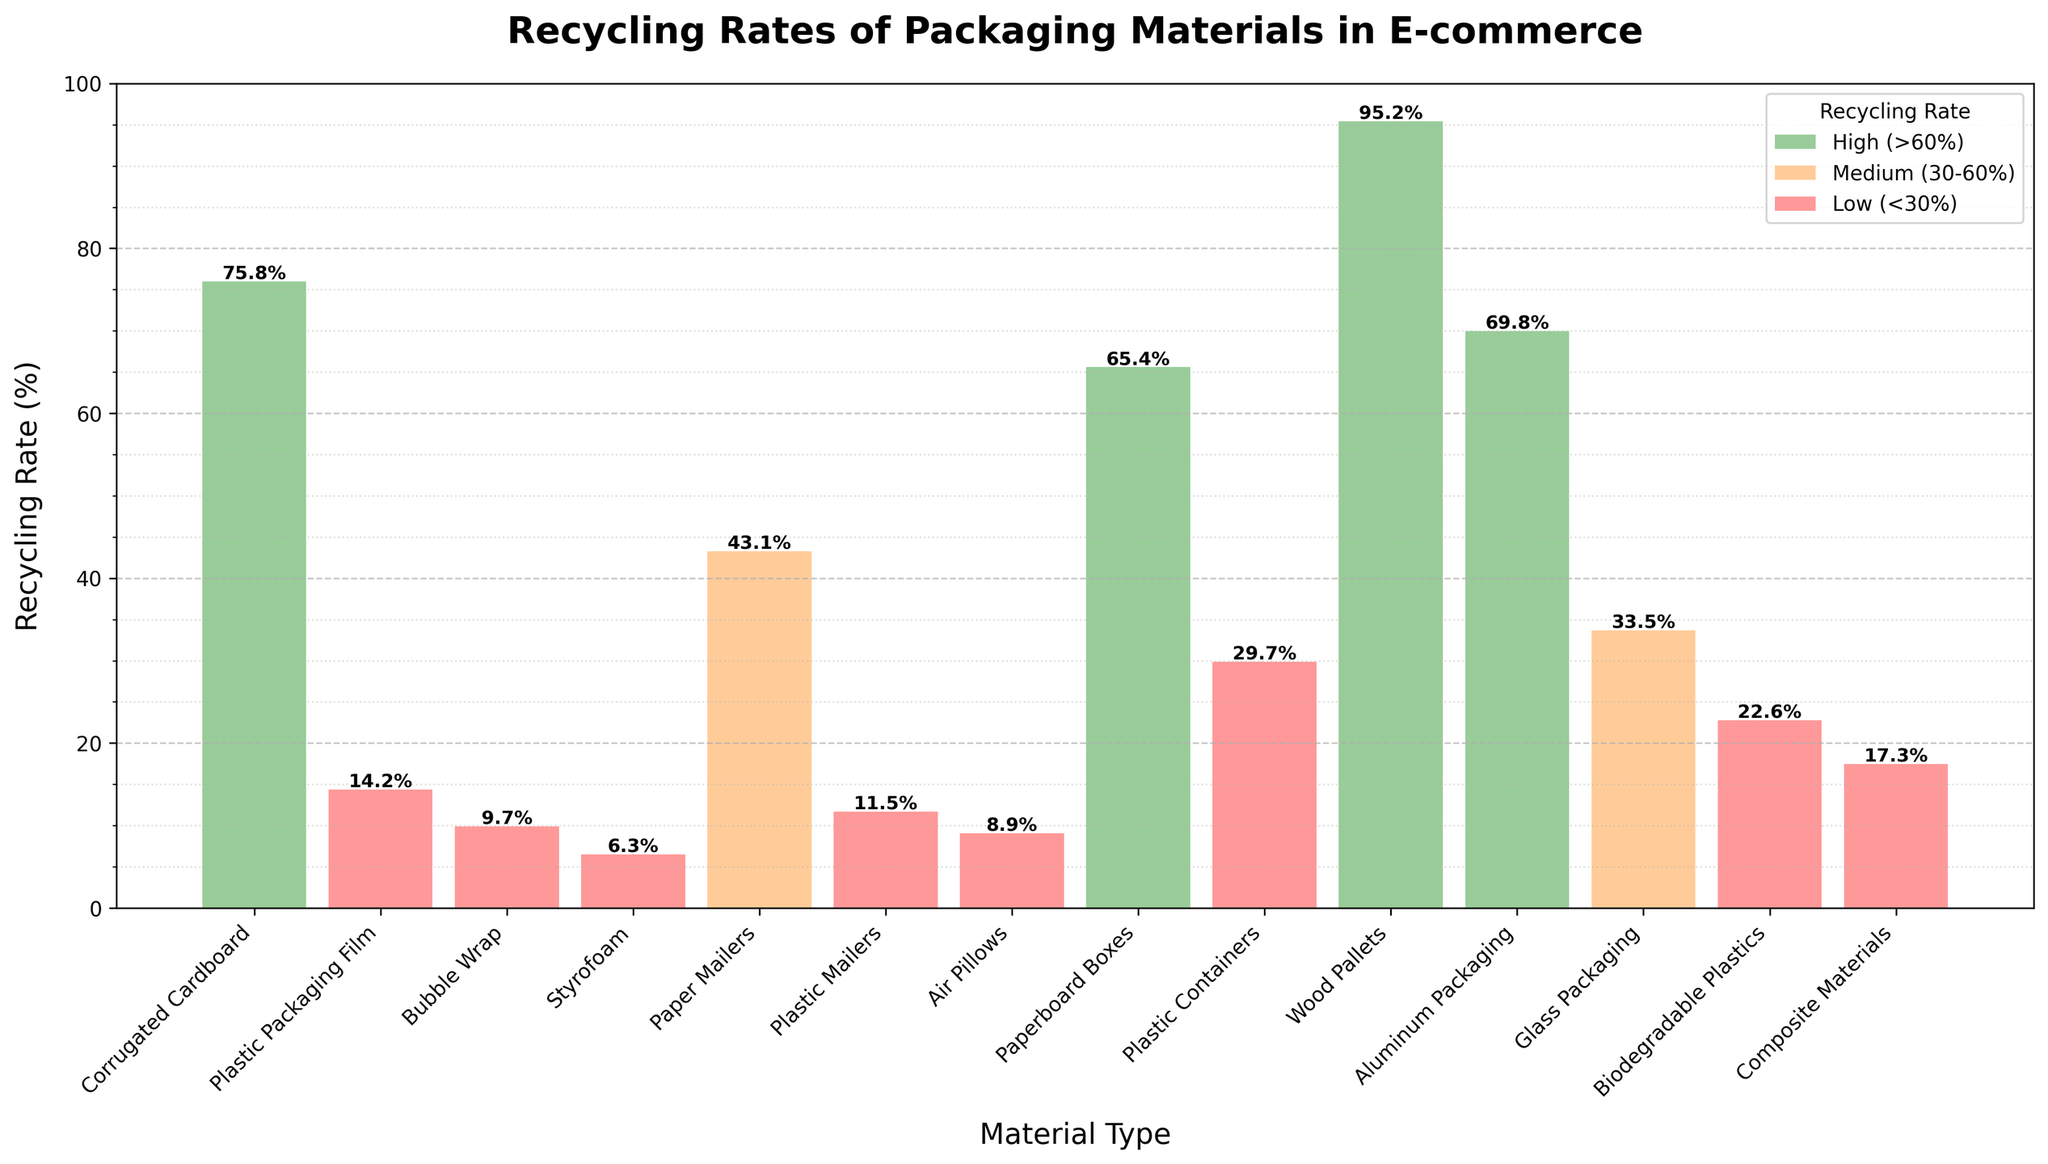Which material has the highest recycling rate? By observing the height of the bars, Wood Pallets has the tallest bar which represents the highest recycling rate.
Answer: Wood Pallets Which material has the lowest recycling rate? By looking at the height of the bars, Styrofoam has the shortest bar which represents the lowest recycling rate.
Answer: Styrofoam What is the difference between the recycling rates of Corrugated Cardboard and Plastic Packaging Film? The recycling rate of Corrugated Cardboard is 75.8% and Plastic Packaging Film is 14.2%. Subtracting these two values gives the difference: 75.8% - 14.2% = 61.6%.
Answer: 61.6% How many materials have a recycling rate above 60%? By examining the bars, the materials with recycling rates above 60% are Corrugated Cardboard, Wood Pallets, Aluminum Packaging, and Paperboard Boxes. There are 4 materials in total.
Answer: 4 Which color is used to represent materials with a recycling rate of less than 30%? By analyzing the colors of the bars and the legend, materials with a recycling rate of less than 30% are labeled with the pinkish-red color.
Answer: Pinkish-red What are the recycling rates for materials represented by the yellowish-orange bars? According to the legend, yellowish-orange bars indicate a recycling rate between 30% and 60%. The materials with these bars and their recycling rates are: 
- Paper Mailers: 43.1%
- Plastic Containers: 29.7%
- Glass Packaging: 33.5%
Answer: Paper Mailers: 43.1%, Plastic Containers: 29.7%, Glass Packaging: 33.5% Which material's recycling rate is closest to the median recycling rate of all materials? To find the median, sort the recycling rates in ascending order: 6.3, 8.9, 9.7, 11.5, 14.2, 17.3, 22.6, 29.7, 33.5, 43.1, 65.4, 69.8, 75.8, 95.2. The median is the average of the 7th and 8th values: (22.6 + 29.7) / 2 = 26.15. The material closest to 26.15% is Biodegradable Plastics at 22.6%.
Answer: Biodegradable Plastics Are there more materials with recycling rates below 30% than above 60%? Counting the number of bars in each range, there are 8 materials with recycling rates below 30% and 4 materials with recycling rates above 60%. Thus, there are more materials with recycling rates below 30%.
Answer: Yes Which materials fall under the 'Medium (30-60%)' category? By referring to the legend for the yellowish-orange bars and matching them with the materials, the 'Medium (30-60%)' category includes Paper Mailers, Plastic Containers, and Glass Packaging.
Answer: Paper Mailers, Plastic Containers, Glass Packaging What percentage of materials have a recycling rate above 50%? There are 14 materials in total. Materials with a recycling rate above 50% are Corrugated Cardboard, Paperboard Boxes, Aluminum Packaging, and Wood Pallets, thus 4 materials. The percentage is (4/14) * 100 = ~28.6%.
Answer: ~28.6% 